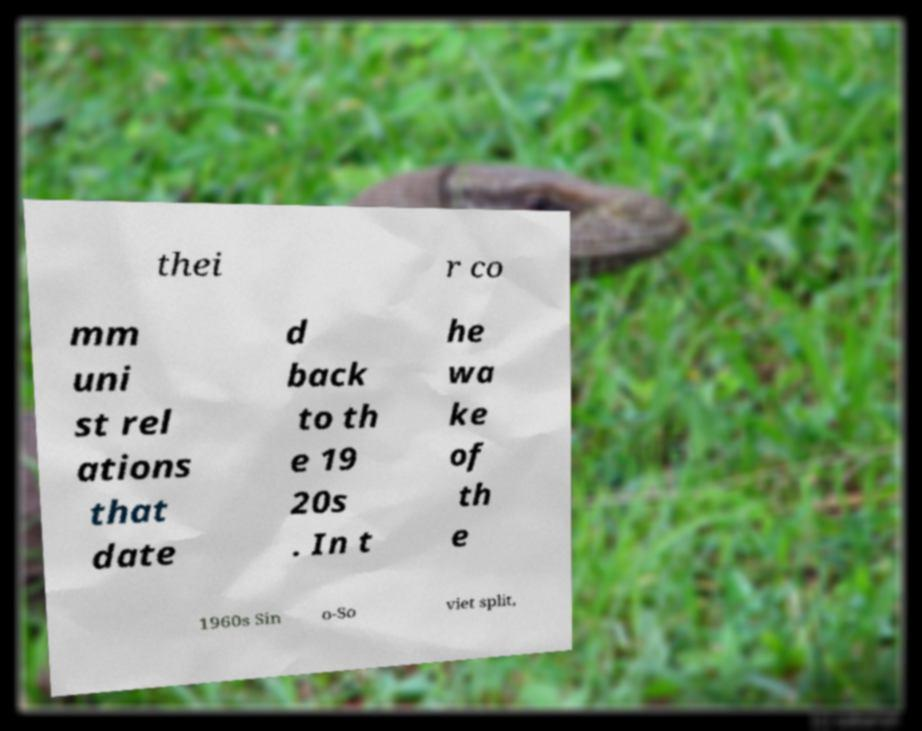Could you extract and type out the text from this image? thei r co mm uni st rel ations that date d back to th e 19 20s . In t he wa ke of th e 1960s Sin o-So viet split, 